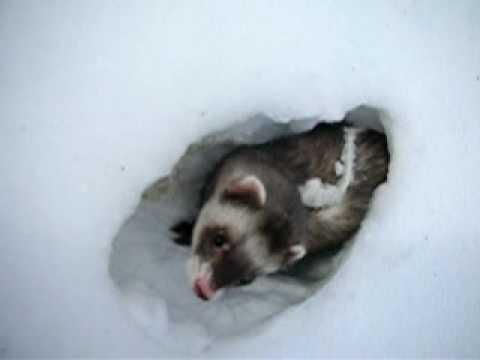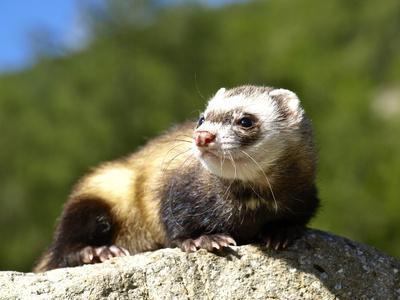The first image is the image on the left, the second image is the image on the right. Analyze the images presented: Is the assertion "The animal in the right image is not in the snow." valid? Answer yes or no. Yes. The first image is the image on the left, the second image is the image on the right. For the images shown, is this caption "The right image has a ferret peeking out of the snow." true? Answer yes or no. No. 